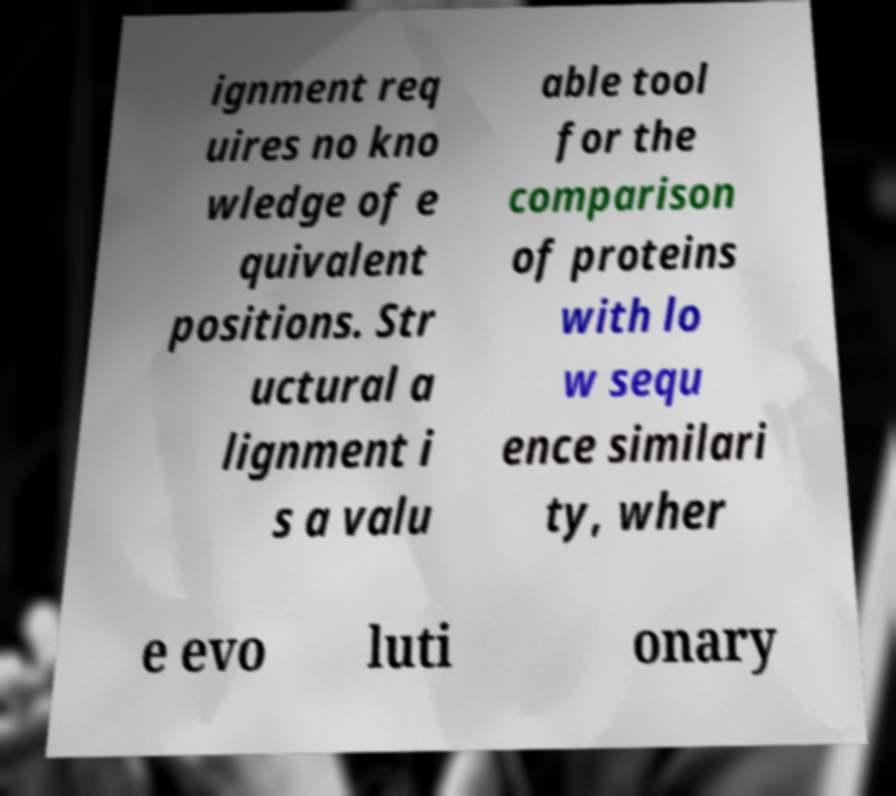For documentation purposes, I need the text within this image transcribed. Could you provide that? ignment req uires no kno wledge of e quivalent positions. Str uctural a lignment i s a valu able tool for the comparison of proteins with lo w sequ ence similari ty, wher e evo luti onary 